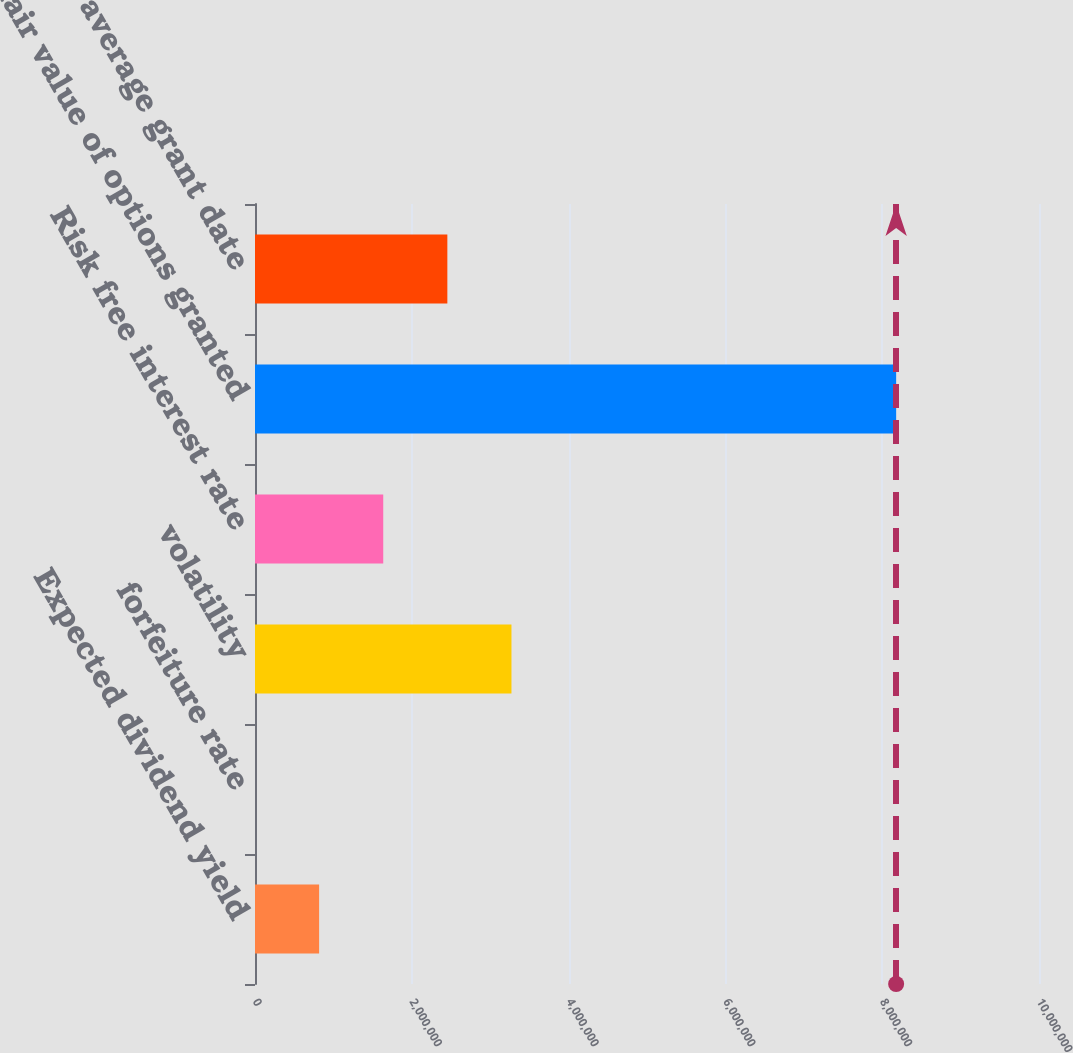Convert chart to OTSL. <chart><loc_0><loc_0><loc_500><loc_500><bar_chart><fcel>Expected dividend yield<fcel>forfeiture rate<fcel>volatility<fcel>Risk free interest rate<fcel>fair value of options granted<fcel>Weighted-average grant date<nl><fcel>817802<fcel>2.46<fcel>3.2712e+06<fcel>1.6356e+06<fcel>8.178e+06<fcel>2.4534e+06<nl></chart> 